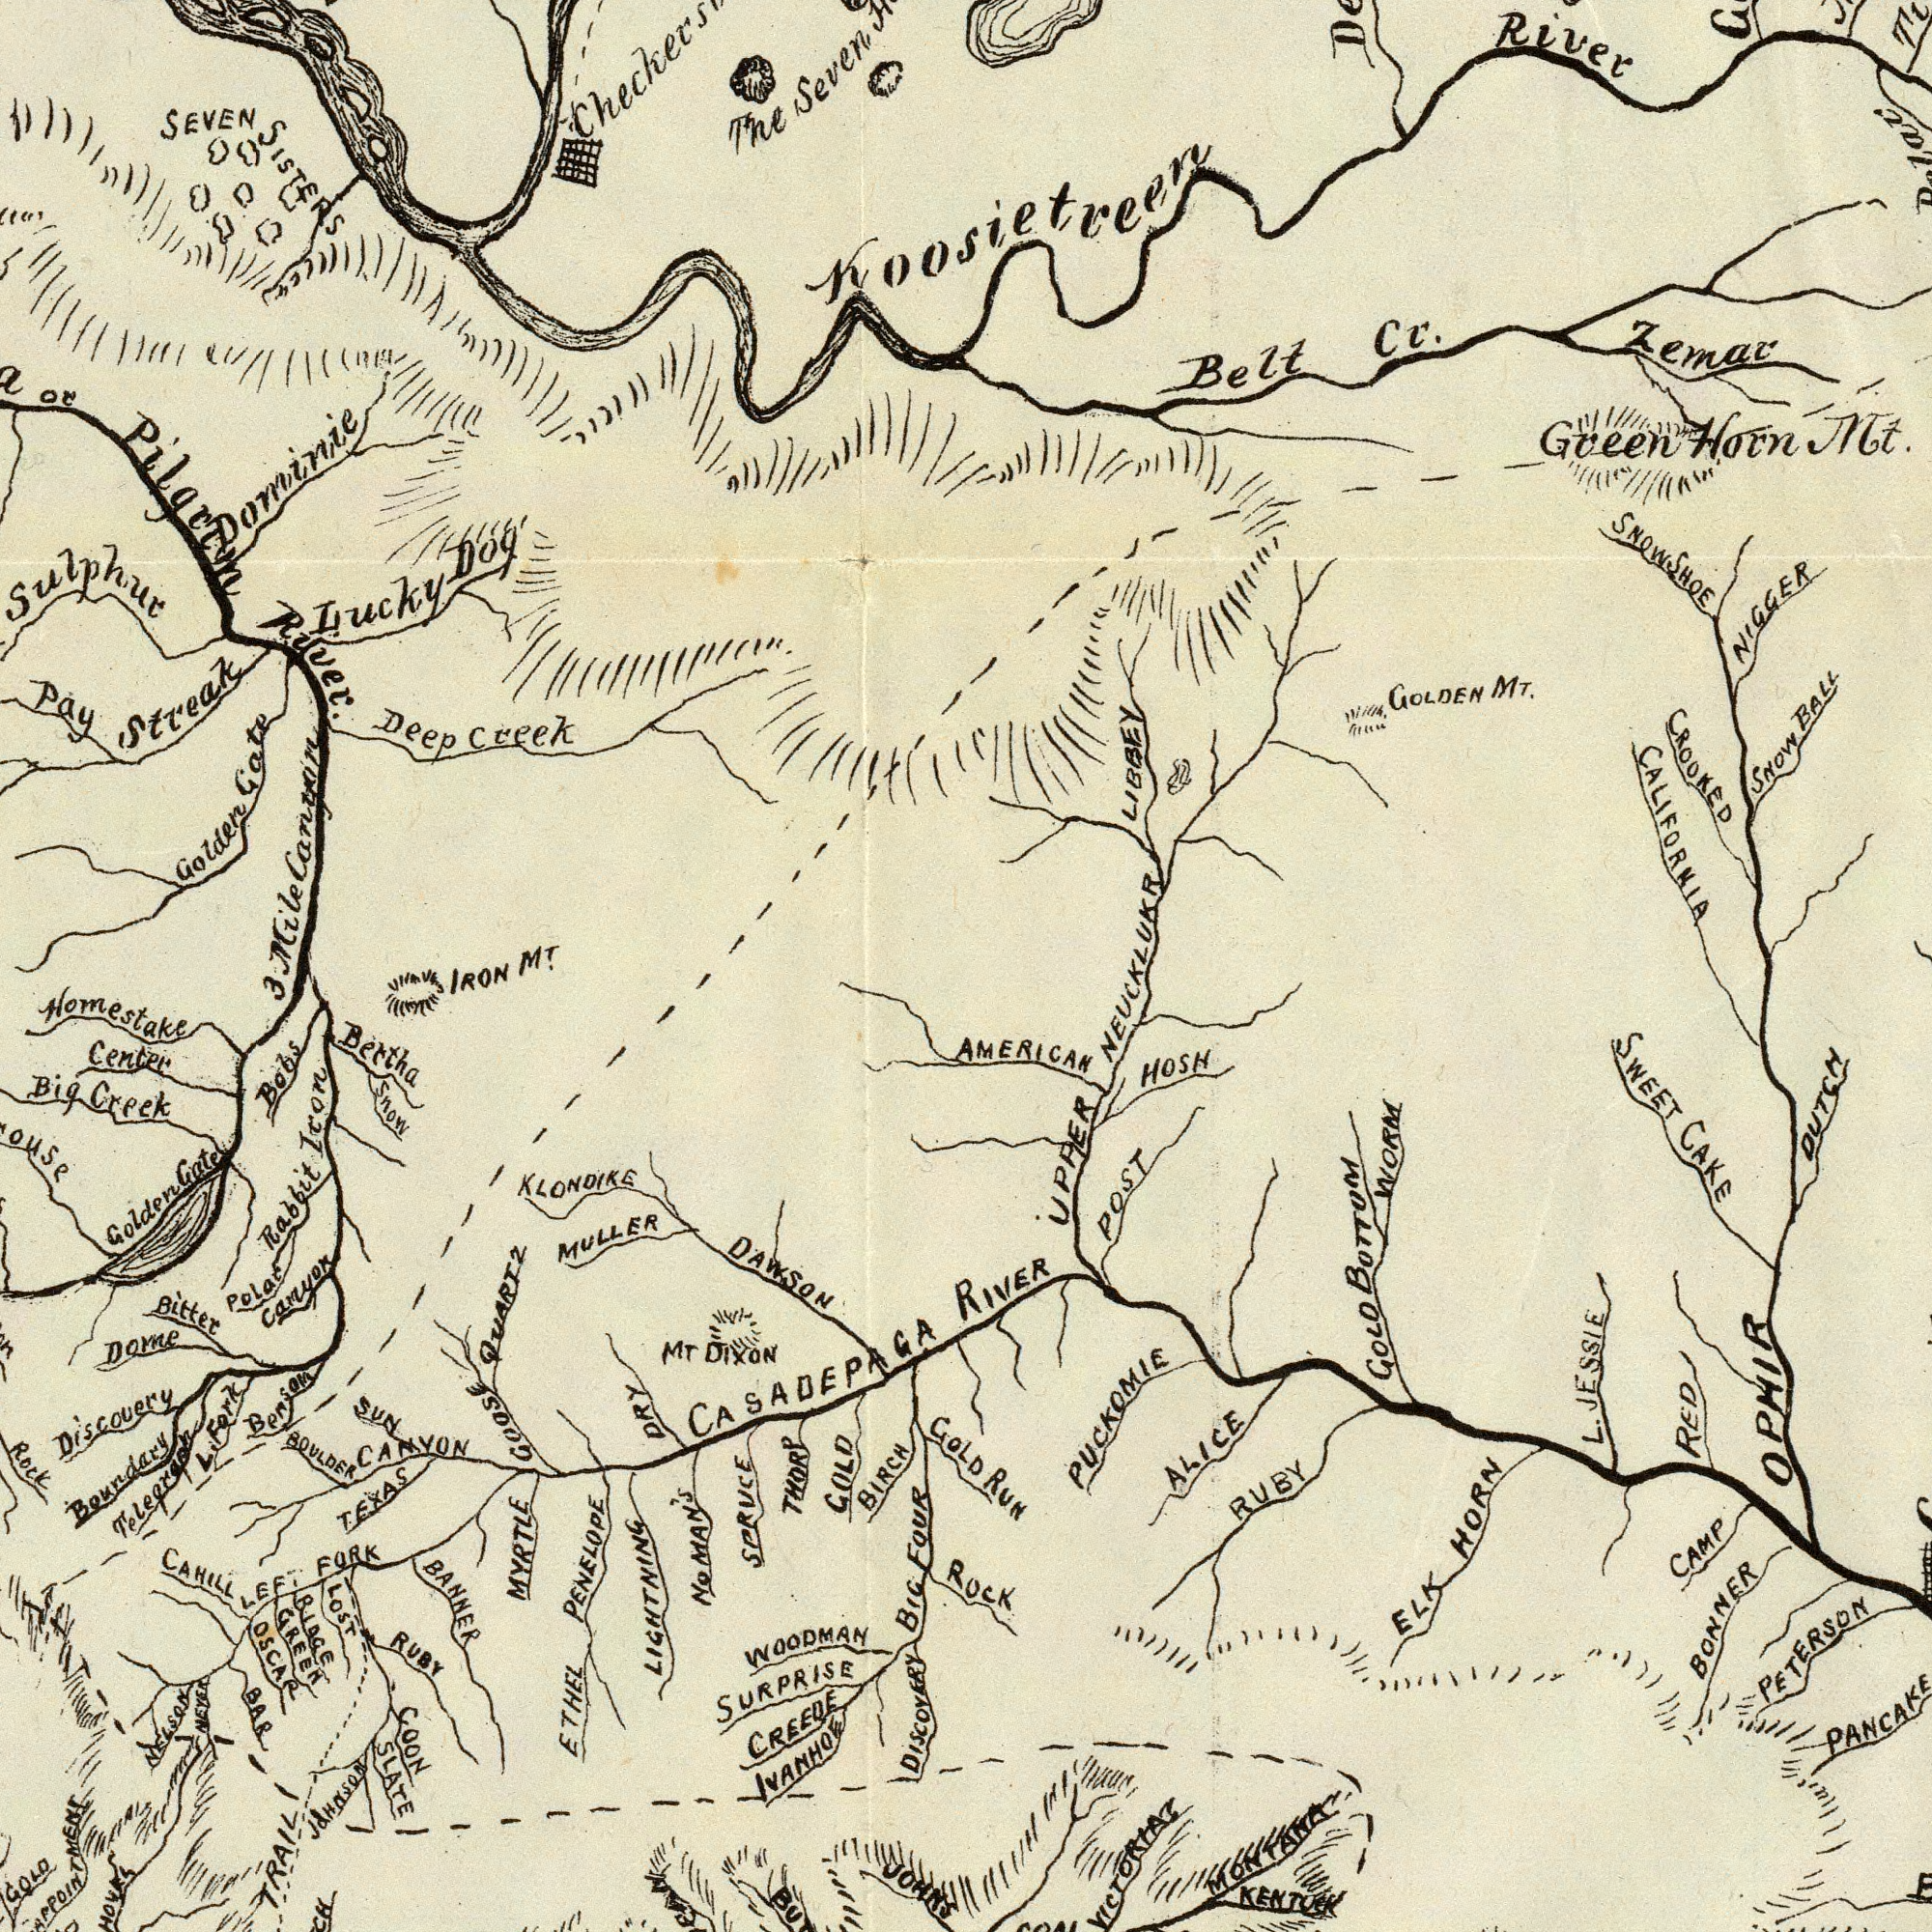What text is visible in the upper-left corner? Sulphur River. Lucky Golden Gate Deep SEVEN Pilgrim Dog The Creek SISTERS Streak Seven or Dominie Pay Mile Cantin M<sup>T</sup>. What text can you see in the bottom-right section? OPHIR VICTORIA MONTANA GOLD BOTTOM SWEET RED BONNER CAKE PETERSON POST HOSH KENTUCK DUTCH RUBY PUCKOMIE ELK UPPER ALICE CAMP PANCAKE HORN WORM AMERICAN RIVER RUN L. JESSIE Rock What text is shown in the bottom-left quadrant? SPRUCE Icon WOODMAN QUARTZ DAWSON BIG Discovery SURPRISE Boundary KLONDIKE OSCAR LIGHTNING THORP Creek BIRCH Dome CREEDE RUBY ETHEL Bertha BOULDER FOUR COON MYRTLE JOHNSON MULLER Center Bitter Big CANYON Rock Snow BAR JOHNS IVANHOE Polar Rabbit Bobs Benson SLATE BANNER TRAIL GOLD DRY PENELOPE Canuox RIDGE Gate CAHILL GREEN GOLD NELSON SUN Golden LOST NEVER Homestake GOOSE DISCOVERY 3 IRON Telegraph L. Fork TEXAS CASADEPAGA MT DIXON NOMAN'S GOLD LEFT FORK What text can you see in the top-right section? CALIFORNIA River SNOWSHOE Cr. Belt NIGGER BALL CROOKED LIBBEY Snow Koosietreen Zemar Green Horn Mt. GOLDEN MT. NEUCKLUKR 